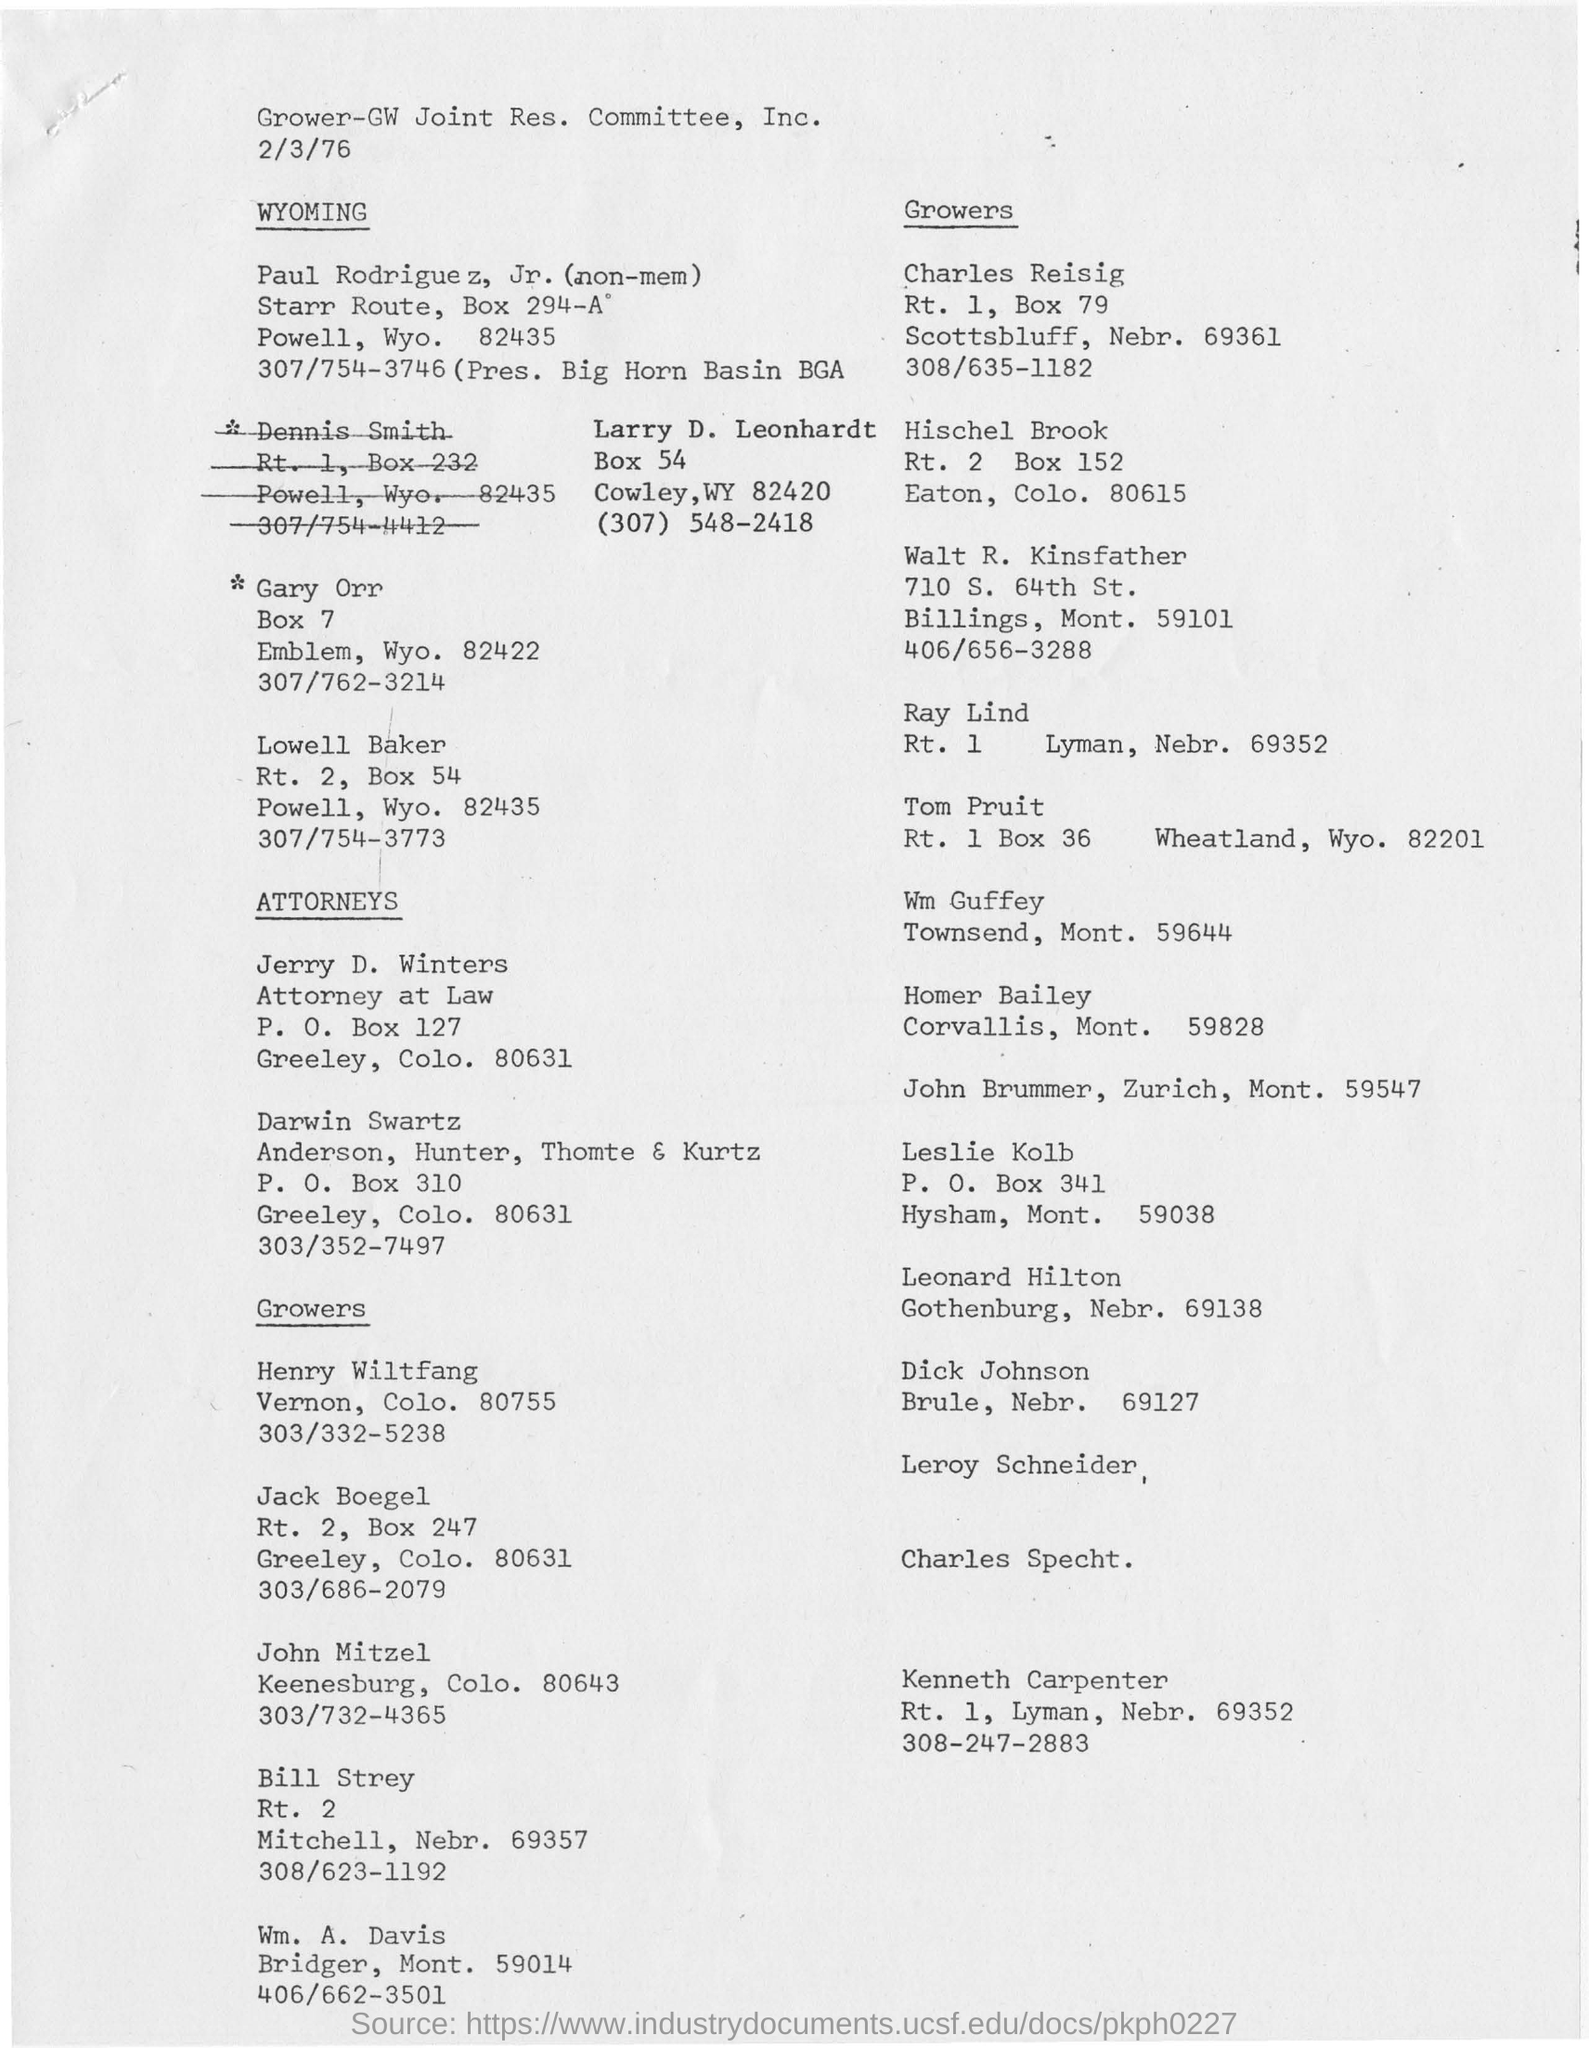Point out several critical features in this image. The Grower-GW Joint Research Committee, Inc. is a committee mentioned. 